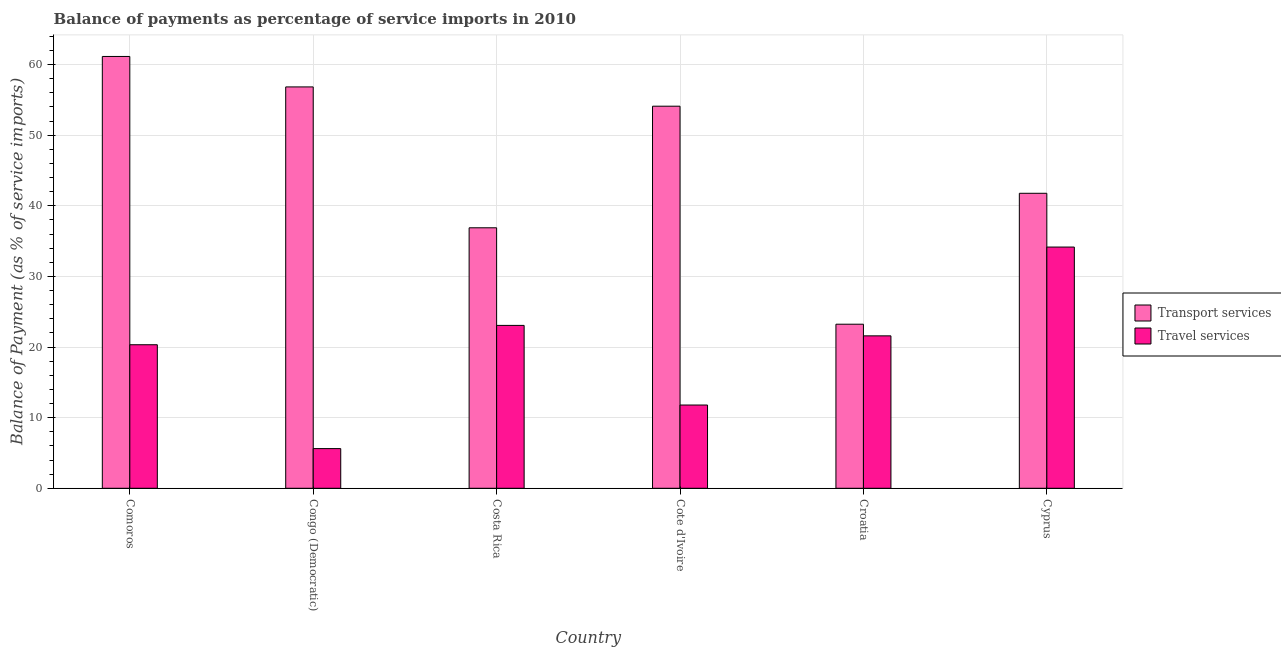How many different coloured bars are there?
Your answer should be compact. 2. How many groups of bars are there?
Offer a very short reply. 6. Are the number of bars per tick equal to the number of legend labels?
Offer a terse response. Yes. How many bars are there on the 3rd tick from the left?
Offer a terse response. 2. What is the label of the 6th group of bars from the left?
Provide a short and direct response. Cyprus. What is the balance of payments of transport services in Comoros?
Your answer should be compact. 61.14. Across all countries, what is the maximum balance of payments of travel services?
Offer a very short reply. 34.15. Across all countries, what is the minimum balance of payments of travel services?
Your answer should be very brief. 5.62. In which country was the balance of payments of travel services maximum?
Offer a terse response. Cyprus. In which country was the balance of payments of travel services minimum?
Offer a very short reply. Congo (Democratic). What is the total balance of payments of transport services in the graph?
Ensure brevity in your answer.  273.93. What is the difference between the balance of payments of transport services in Costa Rica and that in Cote d'Ivoire?
Provide a short and direct response. -17.22. What is the difference between the balance of payments of transport services in Comoros and the balance of payments of travel services in Costa Rica?
Provide a short and direct response. 38.08. What is the average balance of payments of transport services per country?
Give a very brief answer. 45.66. What is the difference between the balance of payments of travel services and balance of payments of transport services in Comoros?
Keep it short and to the point. -40.81. What is the ratio of the balance of payments of travel services in Congo (Democratic) to that in Croatia?
Provide a short and direct response. 0.26. Is the balance of payments of travel services in Croatia less than that in Cyprus?
Offer a terse response. Yes. Is the difference between the balance of payments of transport services in Costa Rica and Cyprus greater than the difference between the balance of payments of travel services in Costa Rica and Cyprus?
Make the answer very short. Yes. What is the difference between the highest and the second highest balance of payments of transport services?
Offer a terse response. 4.31. What is the difference between the highest and the lowest balance of payments of travel services?
Keep it short and to the point. 28.53. What does the 1st bar from the left in Croatia represents?
Offer a very short reply. Transport services. What does the 2nd bar from the right in Costa Rica represents?
Keep it short and to the point. Transport services. How many bars are there?
Provide a short and direct response. 12. Are all the bars in the graph horizontal?
Give a very brief answer. No. Does the graph contain any zero values?
Keep it short and to the point. No. Where does the legend appear in the graph?
Offer a very short reply. Center right. How many legend labels are there?
Provide a succinct answer. 2. What is the title of the graph?
Give a very brief answer. Balance of payments as percentage of service imports in 2010. Does "Private creditors" appear as one of the legend labels in the graph?
Your answer should be compact. No. What is the label or title of the X-axis?
Keep it short and to the point. Country. What is the label or title of the Y-axis?
Your response must be concise. Balance of Payment (as % of service imports). What is the Balance of Payment (as % of service imports) in Transport services in Comoros?
Your answer should be very brief. 61.14. What is the Balance of Payment (as % of service imports) of Travel services in Comoros?
Your answer should be compact. 20.32. What is the Balance of Payment (as % of service imports) in Transport services in Congo (Democratic)?
Make the answer very short. 56.83. What is the Balance of Payment (as % of service imports) in Travel services in Congo (Democratic)?
Ensure brevity in your answer.  5.62. What is the Balance of Payment (as % of service imports) of Transport services in Costa Rica?
Your answer should be compact. 36.88. What is the Balance of Payment (as % of service imports) of Travel services in Costa Rica?
Provide a short and direct response. 23.06. What is the Balance of Payment (as % of service imports) in Transport services in Cote d'Ivoire?
Offer a terse response. 54.1. What is the Balance of Payment (as % of service imports) in Travel services in Cote d'Ivoire?
Provide a short and direct response. 11.79. What is the Balance of Payment (as % of service imports) in Transport services in Croatia?
Ensure brevity in your answer.  23.23. What is the Balance of Payment (as % of service imports) in Travel services in Croatia?
Your answer should be very brief. 21.58. What is the Balance of Payment (as % of service imports) in Transport services in Cyprus?
Offer a terse response. 41.76. What is the Balance of Payment (as % of service imports) of Travel services in Cyprus?
Keep it short and to the point. 34.15. Across all countries, what is the maximum Balance of Payment (as % of service imports) of Transport services?
Keep it short and to the point. 61.14. Across all countries, what is the maximum Balance of Payment (as % of service imports) of Travel services?
Provide a succinct answer. 34.15. Across all countries, what is the minimum Balance of Payment (as % of service imports) of Transport services?
Offer a very short reply. 23.23. Across all countries, what is the minimum Balance of Payment (as % of service imports) of Travel services?
Offer a very short reply. 5.62. What is the total Balance of Payment (as % of service imports) in Transport services in the graph?
Ensure brevity in your answer.  273.93. What is the total Balance of Payment (as % of service imports) in Travel services in the graph?
Your answer should be very brief. 116.52. What is the difference between the Balance of Payment (as % of service imports) of Transport services in Comoros and that in Congo (Democratic)?
Make the answer very short. 4.31. What is the difference between the Balance of Payment (as % of service imports) of Travel services in Comoros and that in Congo (Democratic)?
Your answer should be compact. 14.7. What is the difference between the Balance of Payment (as % of service imports) of Transport services in Comoros and that in Costa Rica?
Your answer should be very brief. 24.26. What is the difference between the Balance of Payment (as % of service imports) in Travel services in Comoros and that in Costa Rica?
Give a very brief answer. -2.74. What is the difference between the Balance of Payment (as % of service imports) of Transport services in Comoros and that in Cote d'Ivoire?
Give a very brief answer. 7.04. What is the difference between the Balance of Payment (as % of service imports) in Travel services in Comoros and that in Cote d'Ivoire?
Offer a terse response. 8.54. What is the difference between the Balance of Payment (as % of service imports) in Transport services in Comoros and that in Croatia?
Provide a succinct answer. 37.91. What is the difference between the Balance of Payment (as % of service imports) of Travel services in Comoros and that in Croatia?
Provide a succinct answer. -1.26. What is the difference between the Balance of Payment (as % of service imports) of Transport services in Comoros and that in Cyprus?
Make the answer very short. 19.37. What is the difference between the Balance of Payment (as % of service imports) in Travel services in Comoros and that in Cyprus?
Keep it short and to the point. -13.83. What is the difference between the Balance of Payment (as % of service imports) in Transport services in Congo (Democratic) and that in Costa Rica?
Offer a terse response. 19.94. What is the difference between the Balance of Payment (as % of service imports) of Travel services in Congo (Democratic) and that in Costa Rica?
Your answer should be compact. -17.44. What is the difference between the Balance of Payment (as % of service imports) of Transport services in Congo (Democratic) and that in Cote d'Ivoire?
Provide a succinct answer. 2.73. What is the difference between the Balance of Payment (as % of service imports) of Travel services in Congo (Democratic) and that in Cote d'Ivoire?
Offer a terse response. -6.17. What is the difference between the Balance of Payment (as % of service imports) of Transport services in Congo (Democratic) and that in Croatia?
Keep it short and to the point. 33.6. What is the difference between the Balance of Payment (as % of service imports) of Travel services in Congo (Democratic) and that in Croatia?
Provide a short and direct response. -15.96. What is the difference between the Balance of Payment (as % of service imports) in Transport services in Congo (Democratic) and that in Cyprus?
Your answer should be compact. 15.06. What is the difference between the Balance of Payment (as % of service imports) in Travel services in Congo (Democratic) and that in Cyprus?
Provide a succinct answer. -28.54. What is the difference between the Balance of Payment (as % of service imports) in Transport services in Costa Rica and that in Cote d'Ivoire?
Ensure brevity in your answer.  -17.22. What is the difference between the Balance of Payment (as % of service imports) in Travel services in Costa Rica and that in Cote d'Ivoire?
Offer a terse response. 11.27. What is the difference between the Balance of Payment (as % of service imports) of Transport services in Costa Rica and that in Croatia?
Give a very brief answer. 13.65. What is the difference between the Balance of Payment (as % of service imports) of Travel services in Costa Rica and that in Croatia?
Your answer should be compact. 1.48. What is the difference between the Balance of Payment (as % of service imports) of Transport services in Costa Rica and that in Cyprus?
Your answer should be compact. -4.88. What is the difference between the Balance of Payment (as % of service imports) in Travel services in Costa Rica and that in Cyprus?
Provide a succinct answer. -11.09. What is the difference between the Balance of Payment (as % of service imports) in Transport services in Cote d'Ivoire and that in Croatia?
Your answer should be compact. 30.87. What is the difference between the Balance of Payment (as % of service imports) in Travel services in Cote d'Ivoire and that in Croatia?
Make the answer very short. -9.79. What is the difference between the Balance of Payment (as % of service imports) of Transport services in Cote d'Ivoire and that in Cyprus?
Make the answer very short. 12.33. What is the difference between the Balance of Payment (as % of service imports) in Travel services in Cote d'Ivoire and that in Cyprus?
Give a very brief answer. -22.37. What is the difference between the Balance of Payment (as % of service imports) of Transport services in Croatia and that in Cyprus?
Provide a succinct answer. -18.54. What is the difference between the Balance of Payment (as % of service imports) of Travel services in Croatia and that in Cyprus?
Keep it short and to the point. -12.57. What is the difference between the Balance of Payment (as % of service imports) in Transport services in Comoros and the Balance of Payment (as % of service imports) in Travel services in Congo (Democratic)?
Keep it short and to the point. 55.52. What is the difference between the Balance of Payment (as % of service imports) of Transport services in Comoros and the Balance of Payment (as % of service imports) of Travel services in Costa Rica?
Your response must be concise. 38.08. What is the difference between the Balance of Payment (as % of service imports) of Transport services in Comoros and the Balance of Payment (as % of service imports) of Travel services in Cote d'Ivoire?
Keep it short and to the point. 49.35. What is the difference between the Balance of Payment (as % of service imports) in Transport services in Comoros and the Balance of Payment (as % of service imports) in Travel services in Croatia?
Your response must be concise. 39.56. What is the difference between the Balance of Payment (as % of service imports) of Transport services in Comoros and the Balance of Payment (as % of service imports) of Travel services in Cyprus?
Offer a very short reply. 26.98. What is the difference between the Balance of Payment (as % of service imports) of Transport services in Congo (Democratic) and the Balance of Payment (as % of service imports) of Travel services in Costa Rica?
Provide a succinct answer. 33.77. What is the difference between the Balance of Payment (as % of service imports) of Transport services in Congo (Democratic) and the Balance of Payment (as % of service imports) of Travel services in Cote d'Ivoire?
Keep it short and to the point. 45.04. What is the difference between the Balance of Payment (as % of service imports) in Transport services in Congo (Democratic) and the Balance of Payment (as % of service imports) in Travel services in Croatia?
Make the answer very short. 35.25. What is the difference between the Balance of Payment (as % of service imports) of Transport services in Congo (Democratic) and the Balance of Payment (as % of service imports) of Travel services in Cyprus?
Your response must be concise. 22.67. What is the difference between the Balance of Payment (as % of service imports) of Transport services in Costa Rica and the Balance of Payment (as % of service imports) of Travel services in Cote d'Ivoire?
Your answer should be very brief. 25.09. What is the difference between the Balance of Payment (as % of service imports) of Transport services in Costa Rica and the Balance of Payment (as % of service imports) of Travel services in Croatia?
Your answer should be very brief. 15.3. What is the difference between the Balance of Payment (as % of service imports) of Transport services in Costa Rica and the Balance of Payment (as % of service imports) of Travel services in Cyprus?
Ensure brevity in your answer.  2.73. What is the difference between the Balance of Payment (as % of service imports) of Transport services in Cote d'Ivoire and the Balance of Payment (as % of service imports) of Travel services in Croatia?
Your answer should be compact. 32.52. What is the difference between the Balance of Payment (as % of service imports) in Transport services in Cote d'Ivoire and the Balance of Payment (as % of service imports) in Travel services in Cyprus?
Your answer should be compact. 19.94. What is the difference between the Balance of Payment (as % of service imports) in Transport services in Croatia and the Balance of Payment (as % of service imports) in Travel services in Cyprus?
Provide a short and direct response. -10.92. What is the average Balance of Payment (as % of service imports) of Transport services per country?
Offer a very short reply. 45.66. What is the average Balance of Payment (as % of service imports) in Travel services per country?
Make the answer very short. 19.42. What is the difference between the Balance of Payment (as % of service imports) in Transport services and Balance of Payment (as % of service imports) in Travel services in Comoros?
Offer a very short reply. 40.81. What is the difference between the Balance of Payment (as % of service imports) of Transport services and Balance of Payment (as % of service imports) of Travel services in Congo (Democratic)?
Your response must be concise. 51.21. What is the difference between the Balance of Payment (as % of service imports) in Transport services and Balance of Payment (as % of service imports) in Travel services in Costa Rica?
Give a very brief answer. 13.82. What is the difference between the Balance of Payment (as % of service imports) in Transport services and Balance of Payment (as % of service imports) in Travel services in Cote d'Ivoire?
Give a very brief answer. 42.31. What is the difference between the Balance of Payment (as % of service imports) of Transport services and Balance of Payment (as % of service imports) of Travel services in Croatia?
Provide a short and direct response. 1.65. What is the difference between the Balance of Payment (as % of service imports) of Transport services and Balance of Payment (as % of service imports) of Travel services in Cyprus?
Your answer should be very brief. 7.61. What is the ratio of the Balance of Payment (as % of service imports) in Transport services in Comoros to that in Congo (Democratic)?
Offer a terse response. 1.08. What is the ratio of the Balance of Payment (as % of service imports) in Travel services in Comoros to that in Congo (Democratic)?
Your answer should be very brief. 3.62. What is the ratio of the Balance of Payment (as % of service imports) in Transport services in Comoros to that in Costa Rica?
Offer a terse response. 1.66. What is the ratio of the Balance of Payment (as % of service imports) of Travel services in Comoros to that in Costa Rica?
Offer a terse response. 0.88. What is the ratio of the Balance of Payment (as % of service imports) in Transport services in Comoros to that in Cote d'Ivoire?
Make the answer very short. 1.13. What is the ratio of the Balance of Payment (as % of service imports) of Travel services in Comoros to that in Cote d'Ivoire?
Give a very brief answer. 1.72. What is the ratio of the Balance of Payment (as % of service imports) in Transport services in Comoros to that in Croatia?
Provide a succinct answer. 2.63. What is the ratio of the Balance of Payment (as % of service imports) of Travel services in Comoros to that in Croatia?
Offer a terse response. 0.94. What is the ratio of the Balance of Payment (as % of service imports) in Transport services in Comoros to that in Cyprus?
Your response must be concise. 1.46. What is the ratio of the Balance of Payment (as % of service imports) in Travel services in Comoros to that in Cyprus?
Offer a very short reply. 0.59. What is the ratio of the Balance of Payment (as % of service imports) in Transport services in Congo (Democratic) to that in Costa Rica?
Your response must be concise. 1.54. What is the ratio of the Balance of Payment (as % of service imports) in Travel services in Congo (Democratic) to that in Costa Rica?
Your response must be concise. 0.24. What is the ratio of the Balance of Payment (as % of service imports) of Transport services in Congo (Democratic) to that in Cote d'Ivoire?
Keep it short and to the point. 1.05. What is the ratio of the Balance of Payment (as % of service imports) of Travel services in Congo (Democratic) to that in Cote d'Ivoire?
Offer a very short reply. 0.48. What is the ratio of the Balance of Payment (as % of service imports) in Transport services in Congo (Democratic) to that in Croatia?
Offer a very short reply. 2.45. What is the ratio of the Balance of Payment (as % of service imports) in Travel services in Congo (Democratic) to that in Croatia?
Your response must be concise. 0.26. What is the ratio of the Balance of Payment (as % of service imports) in Transport services in Congo (Democratic) to that in Cyprus?
Your answer should be very brief. 1.36. What is the ratio of the Balance of Payment (as % of service imports) in Travel services in Congo (Democratic) to that in Cyprus?
Offer a very short reply. 0.16. What is the ratio of the Balance of Payment (as % of service imports) in Transport services in Costa Rica to that in Cote d'Ivoire?
Your answer should be compact. 0.68. What is the ratio of the Balance of Payment (as % of service imports) of Travel services in Costa Rica to that in Cote d'Ivoire?
Your response must be concise. 1.96. What is the ratio of the Balance of Payment (as % of service imports) in Transport services in Costa Rica to that in Croatia?
Your answer should be compact. 1.59. What is the ratio of the Balance of Payment (as % of service imports) in Travel services in Costa Rica to that in Croatia?
Your answer should be very brief. 1.07. What is the ratio of the Balance of Payment (as % of service imports) of Transport services in Costa Rica to that in Cyprus?
Make the answer very short. 0.88. What is the ratio of the Balance of Payment (as % of service imports) in Travel services in Costa Rica to that in Cyprus?
Your response must be concise. 0.68. What is the ratio of the Balance of Payment (as % of service imports) of Transport services in Cote d'Ivoire to that in Croatia?
Provide a short and direct response. 2.33. What is the ratio of the Balance of Payment (as % of service imports) in Travel services in Cote d'Ivoire to that in Croatia?
Your answer should be very brief. 0.55. What is the ratio of the Balance of Payment (as % of service imports) of Transport services in Cote d'Ivoire to that in Cyprus?
Give a very brief answer. 1.3. What is the ratio of the Balance of Payment (as % of service imports) in Travel services in Cote d'Ivoire to that in Cyprus?
Provide a short and direct response. 0.35. What is the ratio of the Balance of Payment (as % of service imports) in Transport services in Croatia to that in Cyprus?
Your answer should be compact. 0.56. What is the ratio of the Balance of Payment (as % of service imports) of Travel services in Croatia to that in Cyprus?
Your answer should be very brief. 0.63. What is the difference between the highest and the second highest Balance of Payment (as % of service imports) of Transport services?
Offer a very short reply. 4.31. What is the difference between the highest and the second highest Balance of Payment (as % of service imports) in Travel services?
Offer a very short reply. 11.09. What is the difference between the highest and the lowest Balance of Payment (as % of service imports) in Transport services?
Offer a very short reply. 37.91. What is the difference between the highest and the lowest Balance of Payment (as % of service imports) of Travel services?
Your response must be concise. 28.54. 